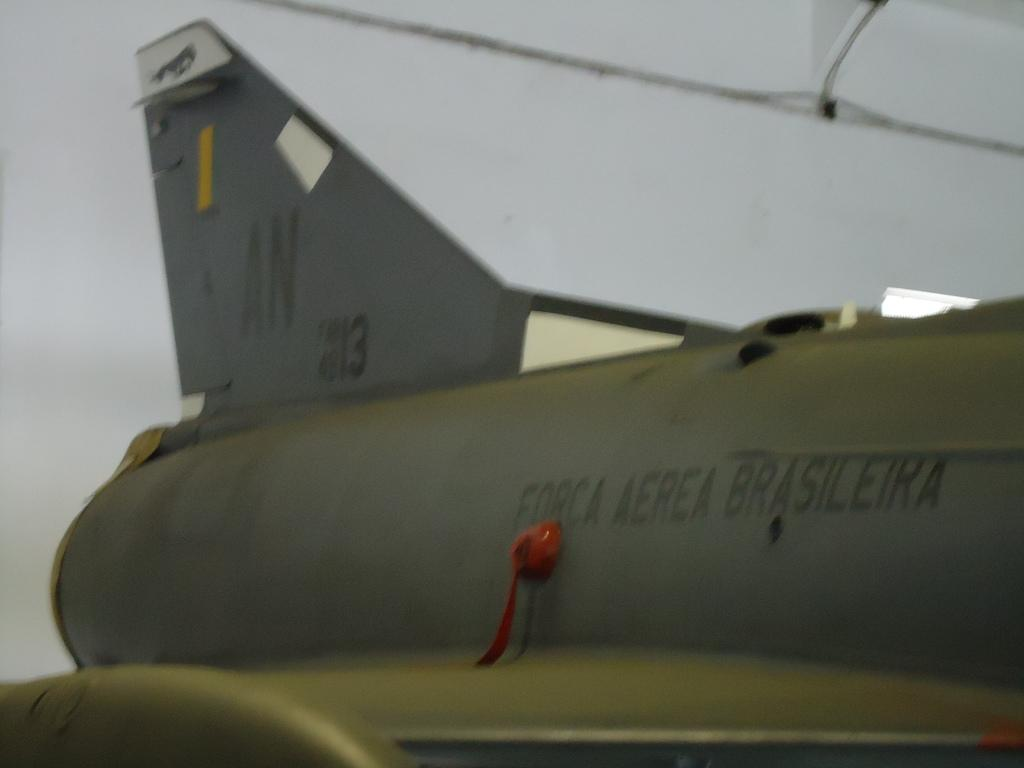<image>
Describe the image concisely. A plane with the letters AN on the tail 